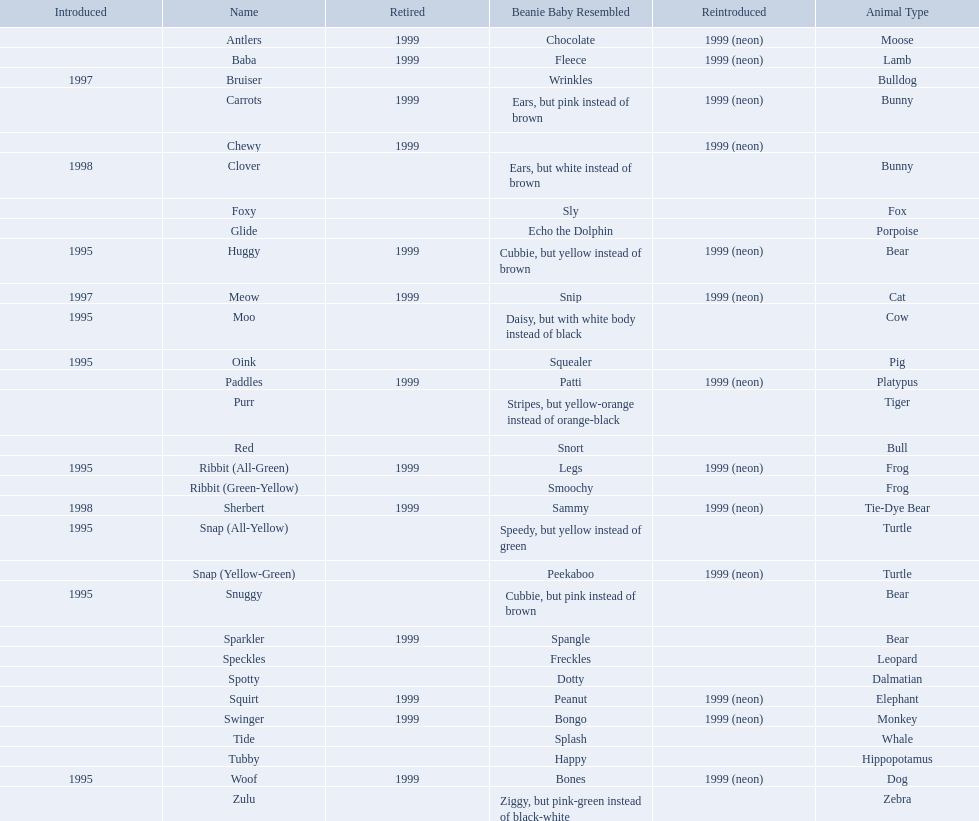What are all the pillow pals? Antlers, Baba, Bruiser, Carrots, Chewy, Clover, Foxy, Glide, Huggy, Meow, Moo, Oink, Paddles, Purr, Red, Ribbit (All-Green), Ribbit (Green-Yellow), Sherbert, Snap (All-Yellow), Snap (Yellow-Green), Snuggy, Sparkler, Speckles, Spotty, Squirt, Swinger, Tide, Tubby, Woof, Zulu. Give me the full table as a dictionary. {'header': ['Introduced', 'Name', 'Retired', 'Beanie Baby Resembled', 'Reintroduced', 'Animal Type'], 'rows': [['', 'Antlers', '1999', 'Chocolate', '1999 (neon)', 'Moose'], ['', 'Baba', '1999', 'Fleece', '1999 (neon)', 'Lamb'], ['1997', 'Bruiser', '', 'Wrinkles', '', 'Bulldog'], ['', 'Carrots', '1999', 'Ears, but pink instead of brown', '1999 (neon)', 'Bunny'], ['', 'Chewy', '1999', '', '1999 (neon)', ''], ['1998', 'Clover', '', 'Ears, but white instead of brown', '', 'Bunny'], ['', 'Foxy', '', 'Sly', '', 'Fox'], ['', 'Glide', '', 'Echo the Dolphin', '', 'Porpoise'], ['1995', 'Huggy', '1999', 'Cubbie, but yellow instead of brown', '1999 (neon)', 'Bear'], ['1997', 'Meow', '1999', 'Snip', '1999 (neon)', 'Cat'], ['1995', 'Moo', '', 'Daisy, but with white body instead of black', '', 'Cow'], ['1995', 'Oink', '', 'Squealer', '', 'Pig'], ['', 'Paddles', '1999', 'Patti', '1999 (neon)', 'Platypus'], ['', 'Purr', '', 'Stripes, but yellow-orange instead of orange-black', '', 'Tiger'], ['', 'Red', '', 'Snort', '', 'Bull'], ['1995', 'Ribbit (All-Green)', '1999', 'Legs', '1999 (neon)', 'Frog'], ['', 'Ribbit (Green-Yellow)', '', 'Smoochy', '', 'Frog'], ['1998', 'Sherbert', '1999', 'Sammy', '1999 (neon)', 'Tie-Dye Bear'], ['1995', 'Snap (All-Yellow)', '', 'Speedy, but yellow instead of green', '', 'Turtle'], ['', 'Snap (Yellow-Green)', '', 'Peekaboo', '1999 (neon)', 'Turtle'], ['1995', 'Snuggy', '', 'Cubbie, but pink instead of brown', '', 'Bear'], ['', 'Sparkler', '1999', 'Spangle', '', 'Bear'], ['', 'Speckles', '', 'Freckles', '', 'Leopard'], ['', 'Spotty', '', 'Dotty', '', 'Dalmatian'], ['', 'Squirt', '1999', 'Peanut', '1999 (neon)', 'Elephant'], ['', 'Swinger', '1999', 'Bongo', '1999 (neon)', 'Monkey'], ['', 'Tide', '', 'Splash', '', 'Whale'], ['', 'Tubby', '', 'Happy', '', 'Hippopotamus'], ['1995', 'Woof', '1999', 'Bones', '1999 (neon)', 'Dog'], ['', 'Zulu', '', 'Ziggy, but pink-green instead of black-white', '', 'Zebra']]} Which is the only without a listed animal type? Chewy. What animals are pillow pals? Moose, Lamb, Bulldog, Bunny, Bunny, Fox, Porpoise, Bear, Cat, Cow, Pig, Platypus, Tiger, Bull, Frog, Frog, Tie-Dye Bear, Turtle, Turtle, Bear, Bear, Leopard, Dalmatian, Elephant, Monkey, Whale, Hippopotamus, Dog, Zebra. What is the name of the dalmatian? Spotty. 